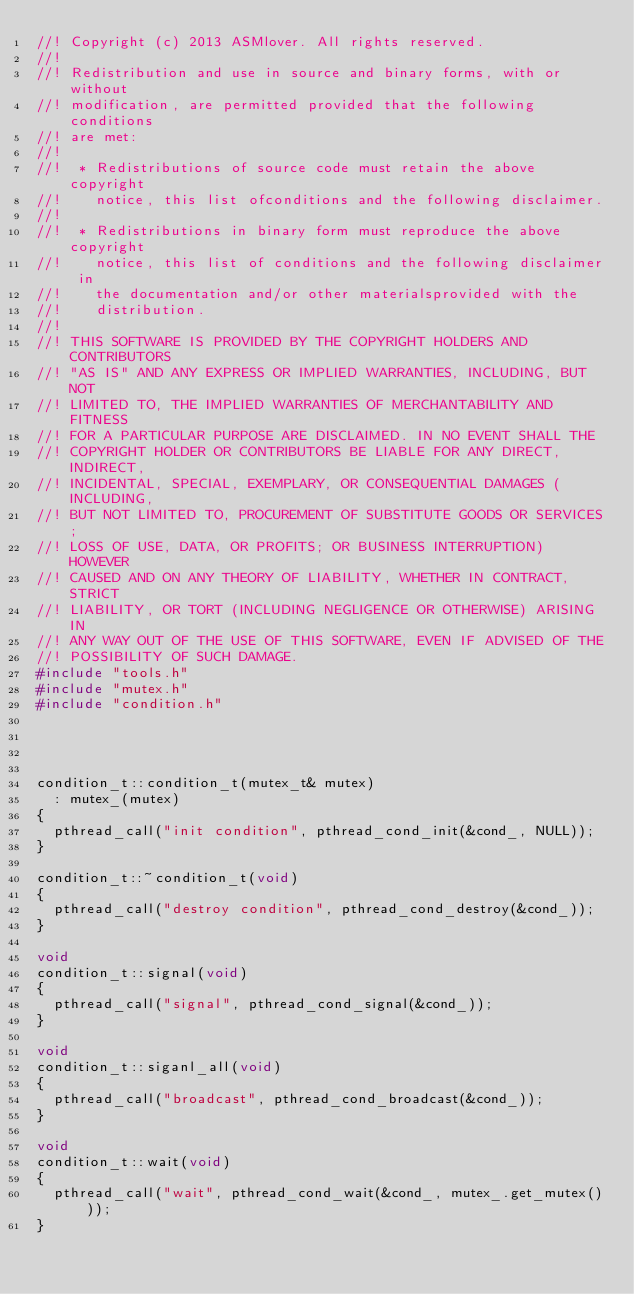Convert code to text. <code><loc_0><loc_0><loc_500><loc_500><_C++_>//! Copyright (c) 2013 ASMlover. All rights reserved.
//!
//! Redistribution and use in source and binary forms, with or without
//! modification, are permitted provided that the following conditions
//! are met:
//!
//!  * Redistributions of source code must retain the above copyright
//!    notice, this list ofconditions and the following disclaimer.
//!
//!  * Redistributions in binary form must reproduce the above copyright
//!    notice, this list of conditions and the following disclaimer in
//!    the documentation and/or other materialsprovided with the
//!    distribution.
//!
//! THIS SOFTWARE IS PROVIDED BY THE COPYRIGHT HOLDERS AND CONTRIBUTORS
//! "AS IS" AND ANY EXPRESS OR IMPLIED WARRANTIES, INCLUDING, BUT NOT
//! LIMITED TO, THE IMPLIED WARRANTIES OF MERCHANTABILITY AND FITNESS
//! FOR A PARTICULAR PURPOSE ARE DISCLAIMED. IN NO EVENT SHALL THE
//! COPYRIGHT HOLDER OR CONTRIBUTORS BE LIABLE FOR ANY DIRECT, INDIRECT,
//! INCIDENTAL, SPECIAL, EXEMPLARY, OR CONSEQUENTIAL DAMAGES (INCLUDING,
//! BUT NOT LIMITED TO, PROCUREMENT OF SUBSTITUTE GOODS OR SERVICES;
//! LOSS OF USE, DATA, OR PROFITS; OR BUSINESS INTERRUPTION) HOWEVER
//! CAUSED AND ON ANY THEORY OF LIABILITY, WHETHER IN CONTRACT, STRICT
//! LIABILITY, OR TORT (INCLUDING NEGLIGENCE OR OTHERWISE) ARISING IN
//! ANY WAY OUT OF THE USE OF THIS SOFTWARE, EVEN IF ADVISED OF THE
//! POSSIBILITY OF SUCH DAMAGE.
#include "tools.h"
#include "mutex.h"
#include "condition.h"




condition_t::condition_t(mutex_t& mutex)
  : mutex_(mutex)
{
  pthread_call("init condition", pthread_cond_init(&cond_, NULL));
}

condition_t::~condition_t(void)
{
  pthread_call("destroy condition", pthread_cond_destroy(&cond_));
}

void 
condition_t::signal(void)
{
  pthread_call("signal", pthread_cond_signal(&cond_));
}

void 
condition_t::siganl_all(void)
{
  pthread_call("broadcast", pthread_cond_broadcast(&cond_));
}

void 
condition_t::wait(void)
{
  pthread_call("wait", pthread_cond_wait(&cond_, mutex_.get_mutex()));
}
</code> 